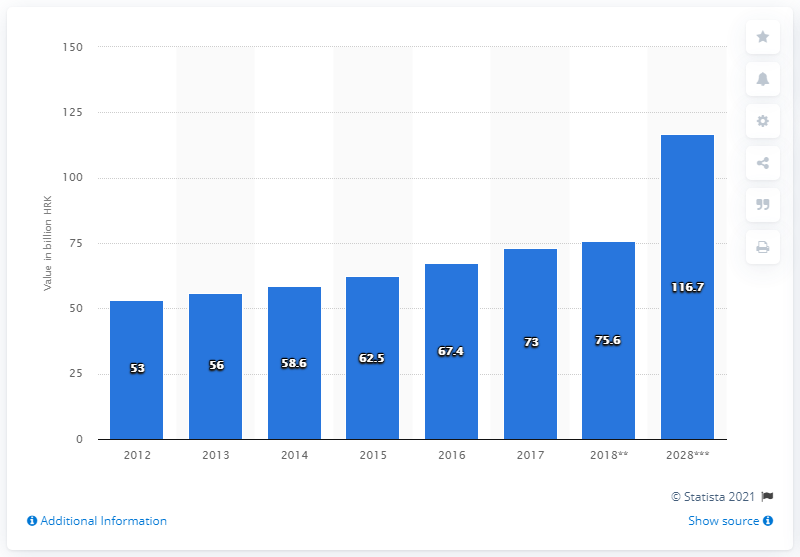Mention a couple of crucial points in this snapshot. In 2017, a total of 73,000 Croatian kuna were exported. 